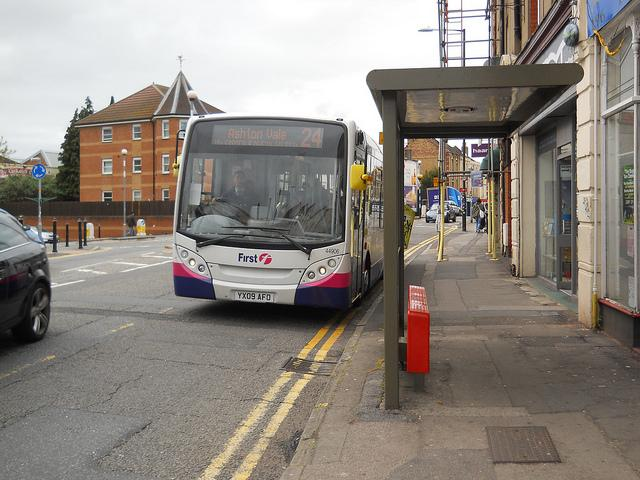Where is this bus headed next?

Choices:
A) jail
B) ashton vale
C) first street
D) 24th street ashton vale 